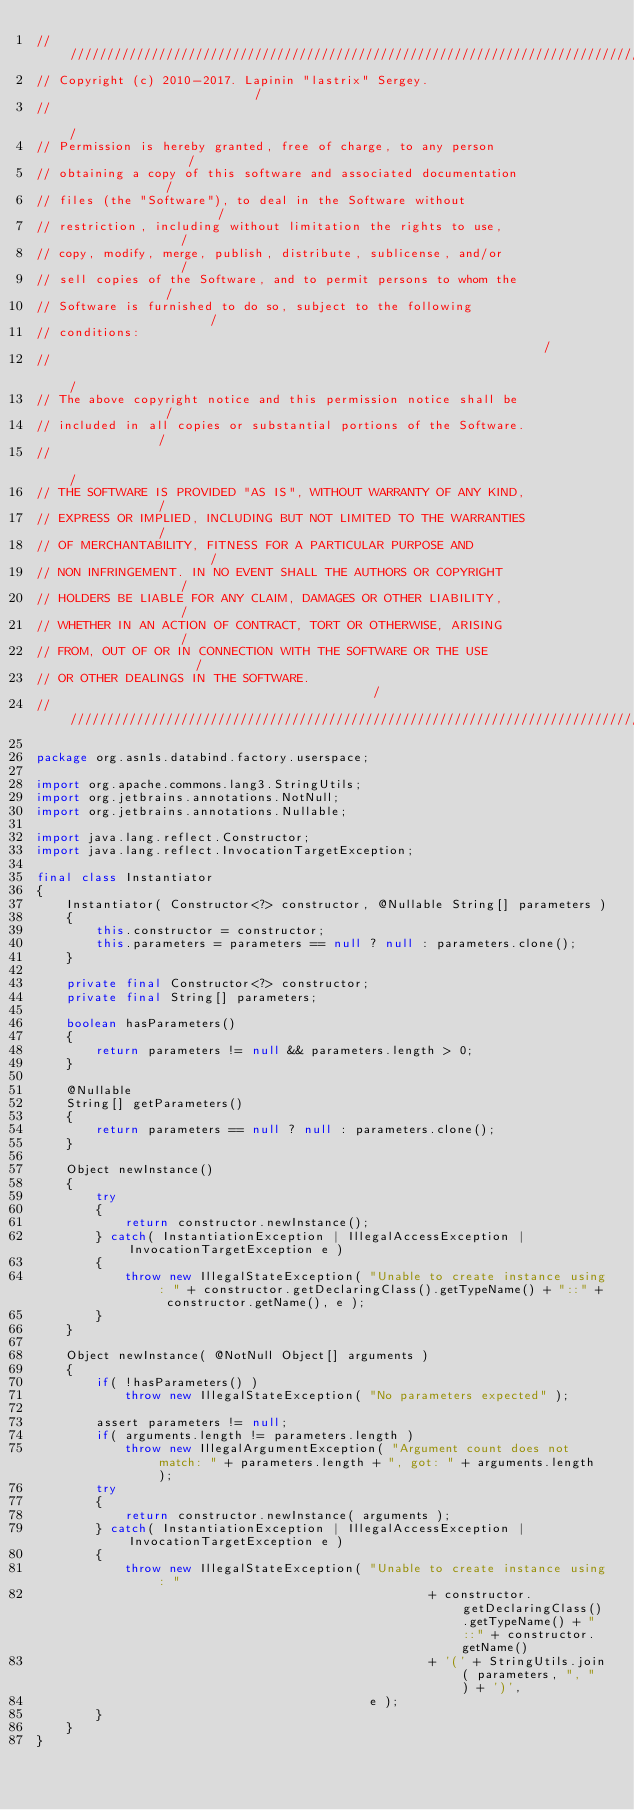Convert code to text. <code><loc_0><loc_0><loc_500><loc_500><_Java_>////////////////////////////////////////////////////////////////////////////////
// Copyright (c) 2010-2017. Lapinin "lastrix" Sergey.                          /
//                                                                             /
// Permission is hereby granted, free of charge, to any person                 /
// obtaining a copy of this software and associated documentation              /
// files (the "Software"), to deal in the Software without                     /
// restriction, including without limitation the rights to use,                /
// copy, modify, merge, publish, distribute, sublicense, and/or                /
// sell copies of the Software, and to permit persons to whom the              /
// Software is furnished to do so, subject to the following                    /
// conditions:                                                                 /
//                                                                             /
// The above copyright notice and this permission notice shall be              /
// included in all copies or substantial portions of the Software.             /
//                                                                             /
// THE SOFTWARE IS PROVIDED "AS IS", WITHOUT WARRANTY OF ANY KIND,             /
// EXPRESS OR IMPLIED, INCLUDING BUT NOT LIMITED TO THE WARRANTIES             /
// OF MERCHANTABILITY, FITNESS FOR A PARTICULAR PURPOSE AND                    /
// NON INFRINGEMENT. IN NO EVENT SHALL THE AUTHORS OR COPYRIGHT                /
// HOLDERS BE LIABLE FOR ANY CLAIM, DAMAGES OR OTHER LIABILITY,                /
// WHETHER IN AN ACTION OF CONTRACT, TORT OR OTHERWISE, ARISING                /
// FROM, OUT OF OR IN CONNECTION WITH THE SOFTWARE OR THE USE                  /
// OR OTHER DEALINGS IN THE SOFTWARE.                                          /
////////////////////////////////////////////////////////////////////////////////

package org.asn1s.databind.factory.userspace;

import org.apache.commons.lang3.StringUtils;
import org.jetbrains.annotations.NotNull;
import org.jetbrains.annotations.Nullable;

import java.lang.reflect.Constructor;
import java.lang.reflect.InvocationTargetException;

final class Instantiator
{
	Instantiator( Constructor<?> constructor, @Nullable String[] parameters )
	{
		this.constructor = constructor;
		this.parameters = parameters == null ? null : parameters.clone();
	}

	private final Constructor<?> constructor;
	private final String[] parameters;

	boolean hasParameters()
	{
		return parameters != null && parameters.length > 0;
	}

	@Nullable
	String[] getParameters()
	{
		return parameters == null ? null : parameters.clone();
	}

	Object newInstance()
	{
		try
		{
			return constructor.newInstance();
		} catch( InstantiationException | IllegalAccessException | InvocationTargetException e )
		{
			throw new IllegalStateException( "Unable to create instance using: " + constructor.getDeclaringClass().getTypeName() + "::" + constructor.getName(), e );
		}
	}

	Object newInstance( @NotNull Object[] arguments )
	{
		if( !hasParameters() )
			throw new IllegalStateException( "No parameters expected" );

		assert parameters != null;
		if( arguments.length != parameters.length )
			throw new IllegalArgumentException( "Argument count does not match: " + parameters.length + ", got: " + arguments.length );
		try
		{
			return constructor.newInstance( arguments );
		} catch( InstantiationException | IllegalAccessException | InvocationTargetException e )
		{
			throw new IllegalStateException( "Unable to create instance using: "
					                                 + constructor.getDeclaringClass().getTypeName() + "::" + constructor.getName()
					                                 + '(' + StringUtils.join( parameters, ", " ) + ')',
			                                 e );
		}
	}
}
</code> 